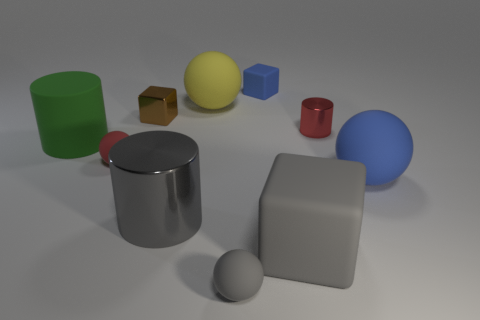Subtract all small cubes. How many cubes are left? 1 Subtract all balls. How many objects are left? 6 Subtract all brown blocks. How many blocks are left? 2 Subtract 1 cubes. How many cubes are left? 2 Subtract all gray cylinders. Subtract all blue balls. How many cylinders are left? 2 Subtract all cyan cubes. How many gray cylinders are left? 1 Subtract all large rubber objects. Subtract all gray rubber things. How many objects are left? 4 Add 6 small rubber objects. How many small rubber objects are left? 9 Add 8 tiny cyan cubes. How many tiny cyan cubes exist? 8 Subtract 0 red blocks. How many objects are left? 10 